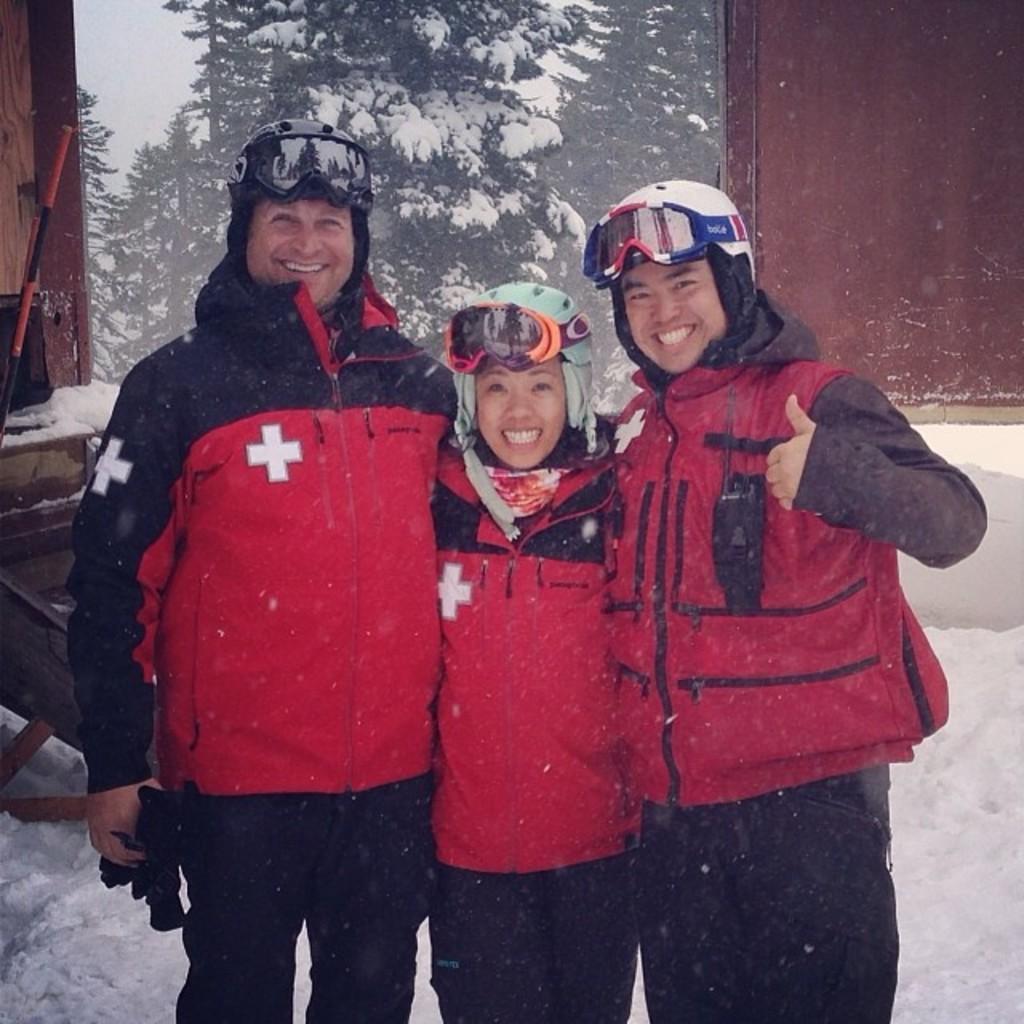Describe this image in one or two sentences. In this image, I can see three people standing and smiling. I can see the trees, which is partially covered with the snow. I think these are the wooden houses. At the bottom of the image, I can see the snow. 